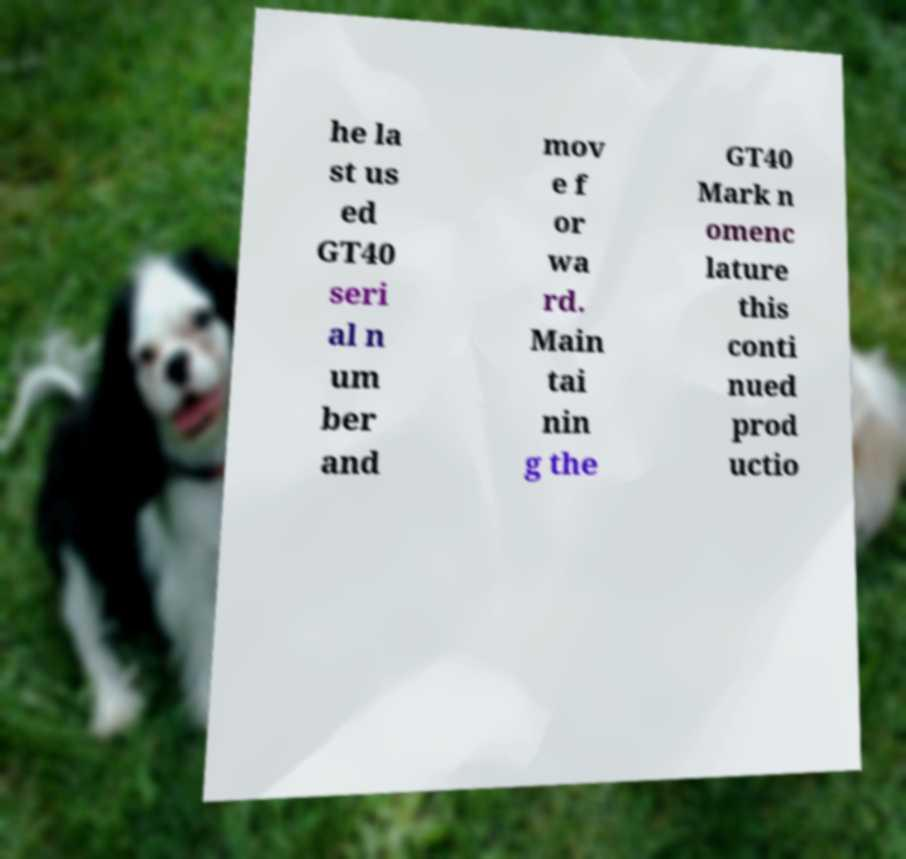There's text embedded in this image that I need extracted. Can you transcribe it verbatim? he la st us ed GT40 seri al n um ber and mov e f or wa rd. Main tai nin g the GT40 Mark n omenc lature this conti nued prod uctio 